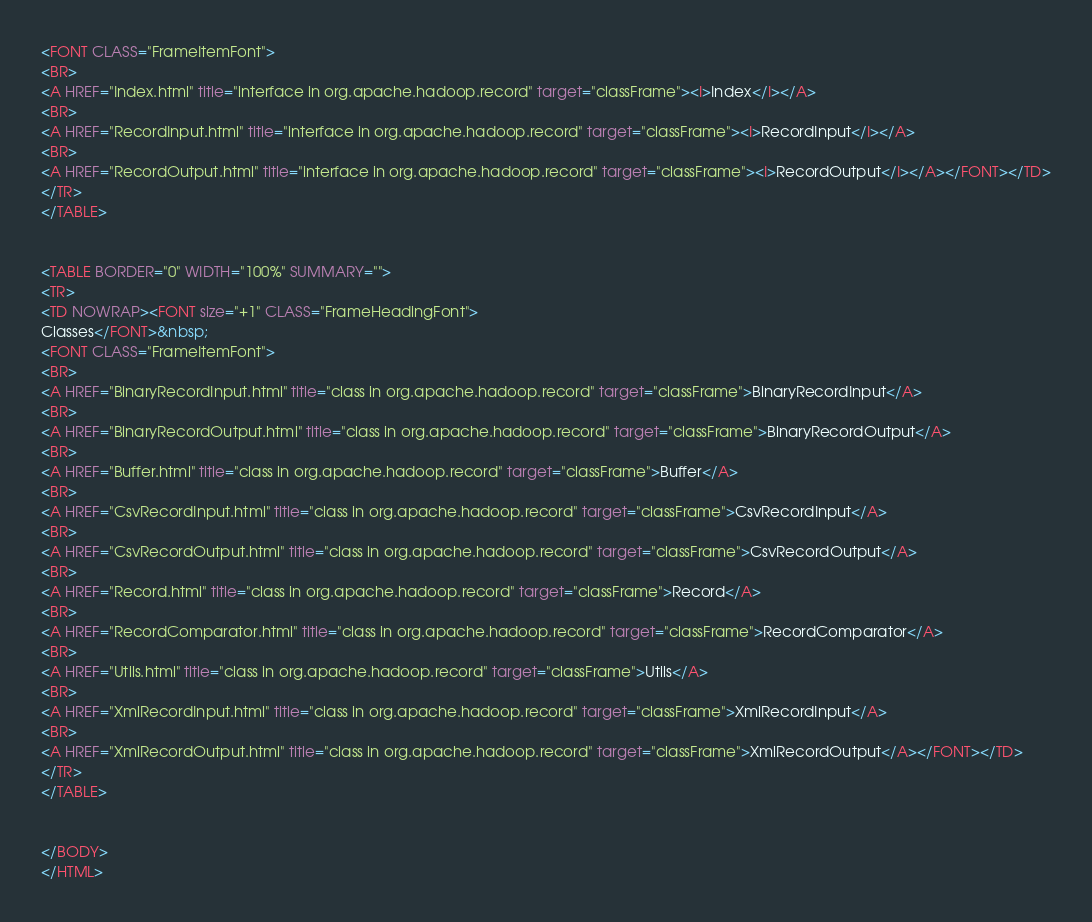Convert code to text. <code><loc_0><loc_0><loc_500><loc_500><_HTML_><FONT CLASS="FrameItemFont">
<BR>
<A HREF="Index.html" title="interface in org.apache.hadoop.record" target="classFrame"><I>Index</I></A>
<BR>
<A HREF="RecordInput.html" title="interface in org.apache.hadoop.record" target="classFrame"><I>RecordInput</I></A>
<BR>
<A HREF="RecordOutput.html" title="interface in org.apache.hadoop.record" target="classFrame"><I>RecordOutput</I></A></FONT></TD>
</TR>
</TABLE>


<TABLE BORDER="0" WIDTH="100%" SUMMARY="">
<TR>
<TD NOWRAP><FONT size="+1" CLASS="FrameHeadingFont">
Classes</FONT>&nbsp;
<FONT CLASS="FrameItemFont">
<BR>
<A HREF="BinaryRecordInput.html" title="class in org.apache.hadoop.record" target="classFrame">BinaryRecordInput</A>
<BR>
<A HREF="BinaryRecordOutput.html" title="class in org.apache.hadoop.record" target="classFrame">BinaryRecordOutput</A>
<BR>
<A HREF="Buffer.html" title="class in org.apache.hadoop.record" target="classFrame">Buffer</A>
<BR>
<A HREF="CsvRecordInput.html" title="class in org.apache.hadoop.record" target="classFrame">CsvRecordInput</A>
<BR>
<A HREF="CsvRecordOutput.html" title="class in org.apache.hadoop.record" target="classFrame">CsvRecordOutput</A>
<BR>
<A HREF="Record.html" title="class in org.apache.hadoop.record" target="classFrame">Record</A>
<BR>
<A HREF="RecordComparator.html" title="class in org.apache.hadoop.record" target="classFrame">RecordComparator</A>
<BR>
<A HREF="Utils.html" title="class in org.apache.hadoop.record" target="classFrame">Utils</A>
<BR>
<A HREF="XmlRecordInput.html" title="class in org.apache.hadoop.record" target="classFrame">XmlRecordInput</A>
<BR>
<A HREF="XmlRecordOutput.html" title="class in org.apache.hadoop.record" target="classFrame">XmlRecordOutput</A></FONT></TD>
</TR>
</TABLE>


</BODY>
</HTML>
</code> 